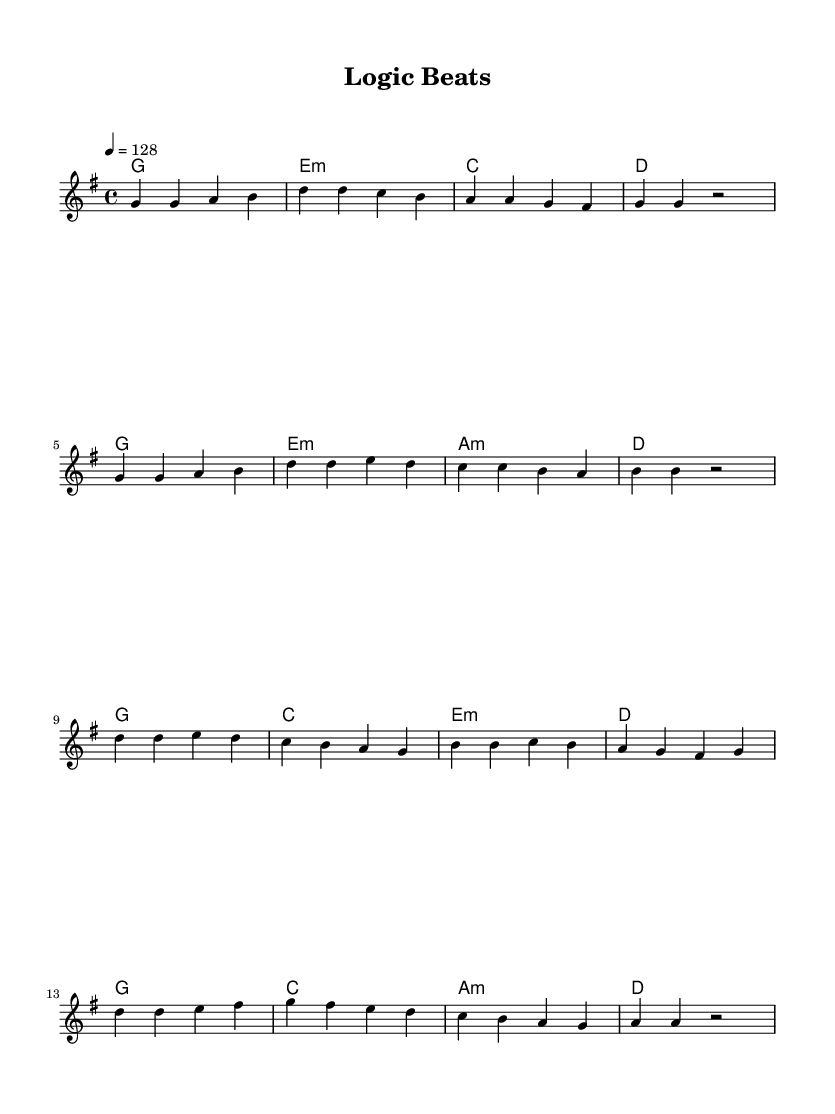What is the key signature of this music? The key signature is G major, which has one sharp (F sharp). This can be identified by looking at the number of sharps indicated in the key signature at the beginning of the staff.
Answer: G major What is the time signature of this music? The time signature is 4/4, meaning there are four beats in each measure and a quarter note receives one beat. This is noted at the beginning of the piece, where "4/4" is specified.
Answer: 4/4 What is the tempo marking for this music? The tempo is set to 128 beats per minute, as indicated by the "4 = 128" marking, which means each quarter note is played at a speed of 128 beats per minute.
Answer: 128 How many phrases are in the verse section? The verse section consists of two phrases, as evidenced by the structure of the melody, which can be divided into two distinct melodic lines separated by measures.
Answer: 2 What is the melody's highest note in the chorus? The highest note in the chorus is D, which can be identified by examining the notes in the chorus section of the sheet music where D appears.
Answer: D How many different chord types are used in the harmonies? There are four different chord types used in the harmonies: G major, E minor, C major, and A minor, as identified by the chord names written above the staff.
Answer: 4 What musical genre does this piece belong to? This piece belongs to K-Pop, which is indicated by the context of the question and the upbeat, catchy style present in the melody and harmonies typical of K-Pop music.
Answer: K-Pop 